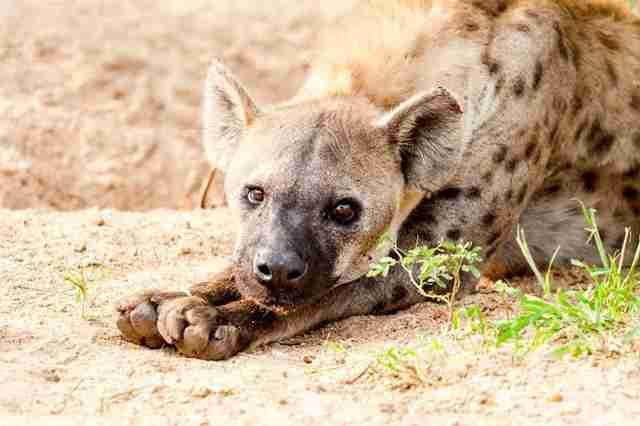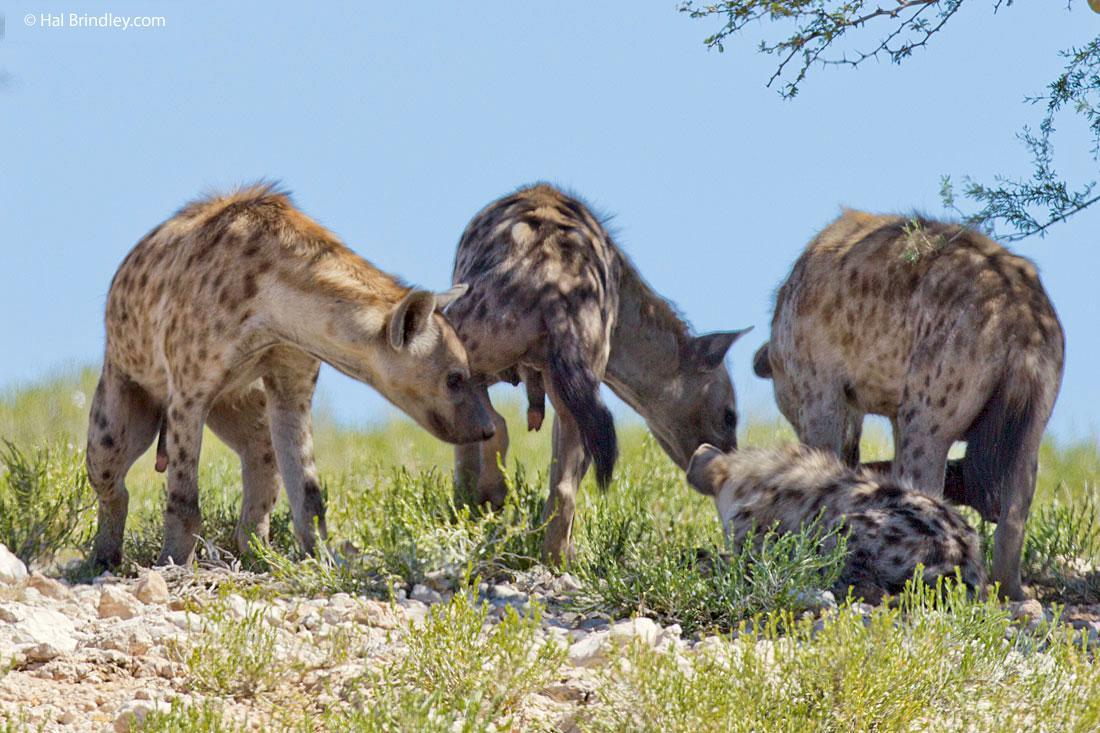The first image is the image on the left, the second image is the image on the right. Evaluate the accuracy of this statement regarding the images: "One image contains at least four hyenas.". Is it true? Answer yes or no. Yes. The first image is the image on the left, the second image is the image on the right. For the images shown, is this caption "There are at least three spotted hyenas gathered together in the right image." true? Answer yes or no. Yes. 